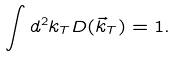<formula> <loc_0><loc_0><loc_500><loc_500>\int d ^ { 2 } k _ { T } D ( \vec { k } _ { T } ) = 1 .</formula> 